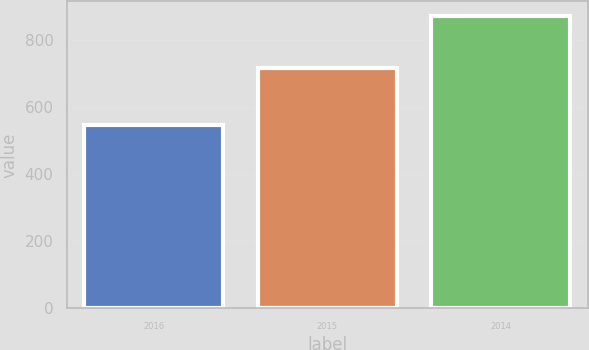Convert chart to OTSL. <chart><loc_0><loc_0><loc_500><loc_500><bar_chart><fcel>2016<fcel>2015<fcel>2014<nl><fcel>549<fcel>718<fcel>873<nl></chart> 